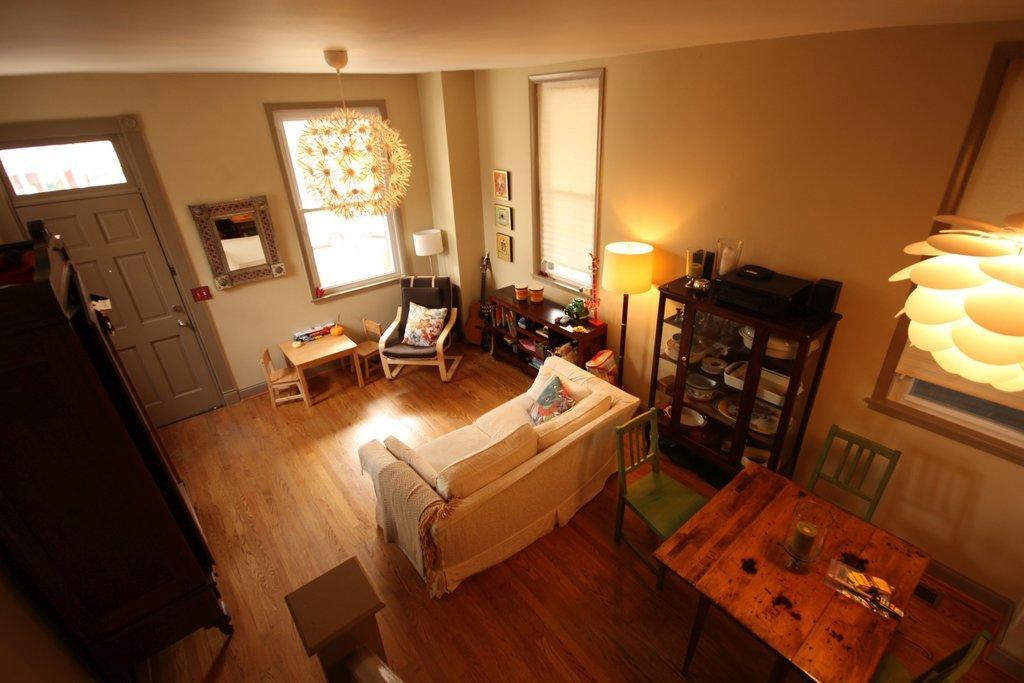Could you give a brief overview of what you see in this image? This image is taken in the living room. In the center of the image there is sofa set. On the left side of the image we can see cupboards. On the right side of the image we can see table, chairs, objects placed in shelves, table, books, chair. In the background we can see wall, windows, photo frames, mirror and door. 